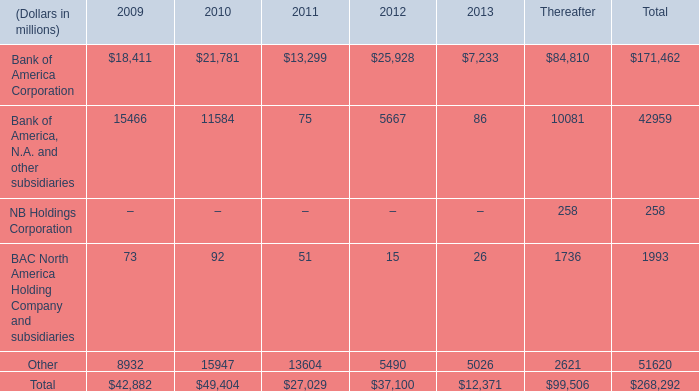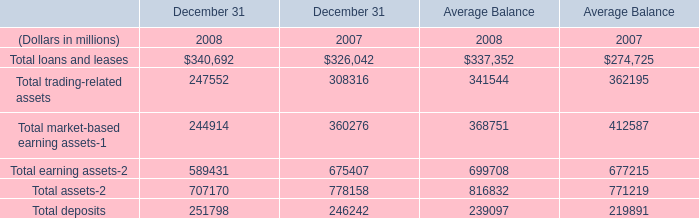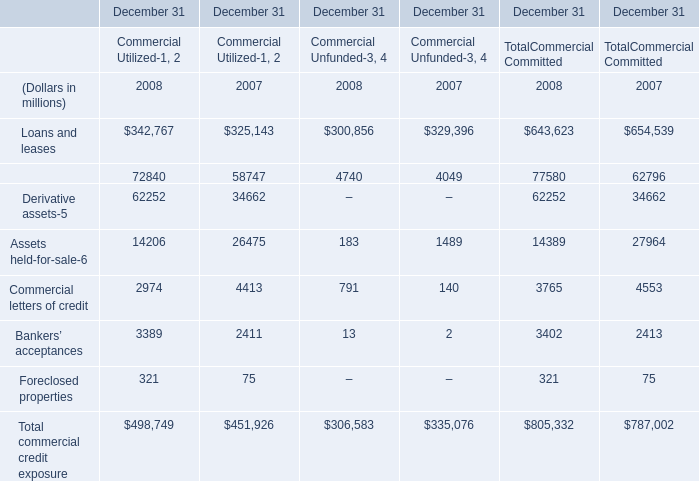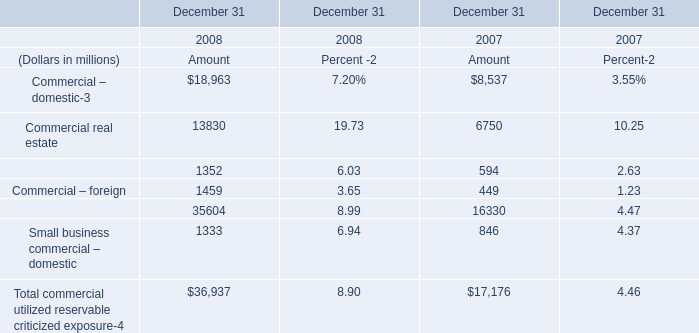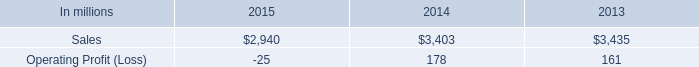what percentage of consumer packaging sales where from north american consumer packaging in 2014? 
Computations: ((2 * 1000) / 3403)
Answer: 0.58772. 